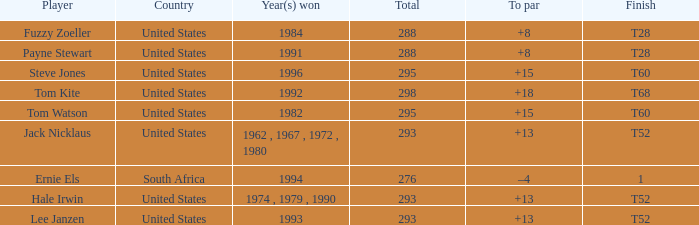Who is the player who won in 1994? Ernie Els. 